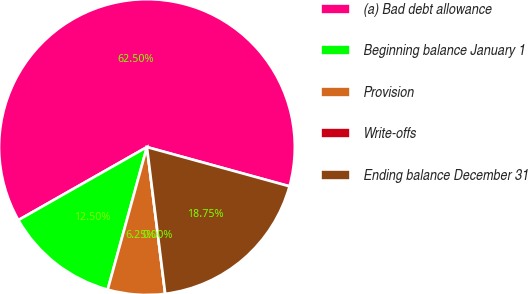Convert chart to OTSL. <chart><loc_0><loc_0><loc_500><loc_500><pie_chart><fcel>(a) Bad debt allowance<fcel>Beginning balance January 1<fcel>Provision<fcel>Write-offs<fcel>Ending balance December 31<nl><fcel>62.49%<fcel>12.5%<fcel>6.25%<fcel>0.0%<fcel>18.75%<nl></chart> 